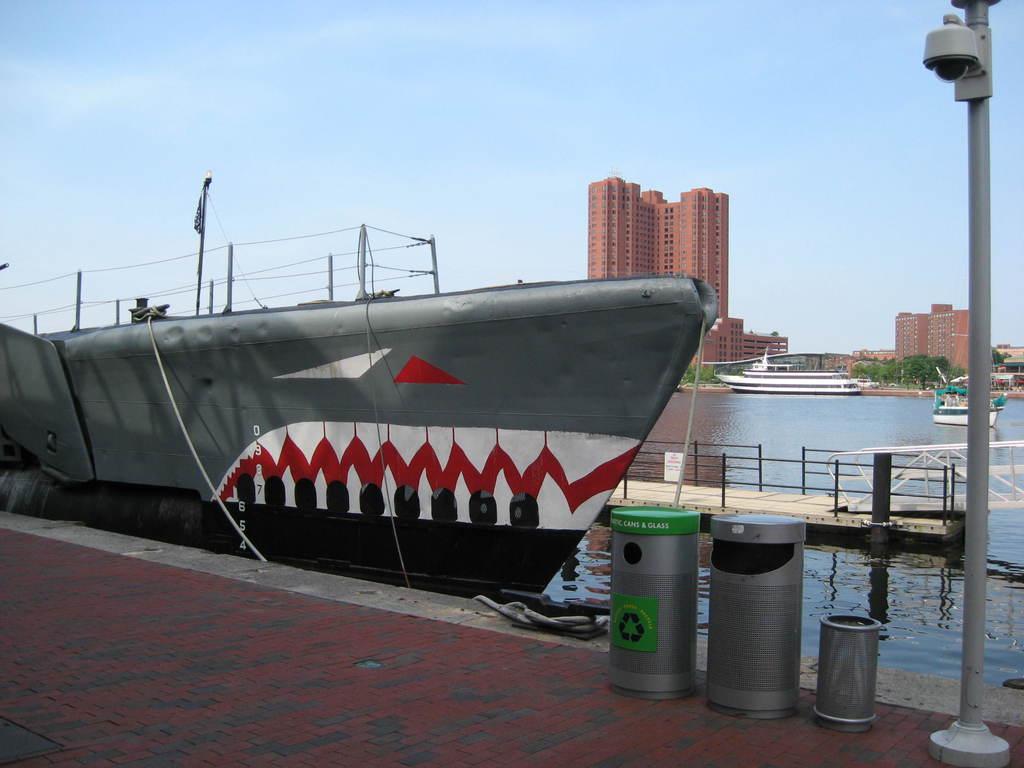What does the recycle bin say?
Make the answer very short. Unanswerable. 